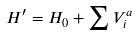Convert formula to latex. <formula><loc_0><loc_0><loc_500><loc_500>H ^ { \prime } = H _ { 0 } + \sum V _ { i } ^ { a }</formula> 